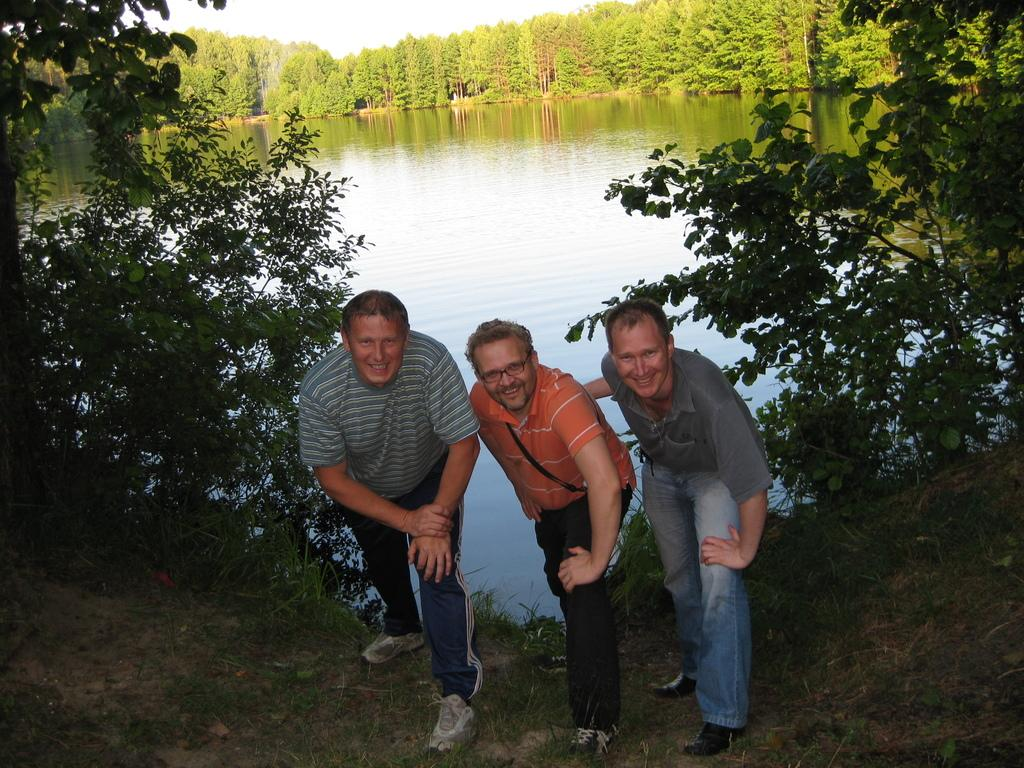How many people are in the image? There are three men in the image. What are the men standing in front of? The men are standing in front of a pond. What can be seen on either side of the pond? There are trees on either side of the pond. What is visible in the background of the image? There are trees and the sky visible in the background of the image. What type of butter is being used in the meeting depicted in the image? There is no meeting or butter present in the image; it features three men standing in front of a pond with trees and the sky visible in the background. 